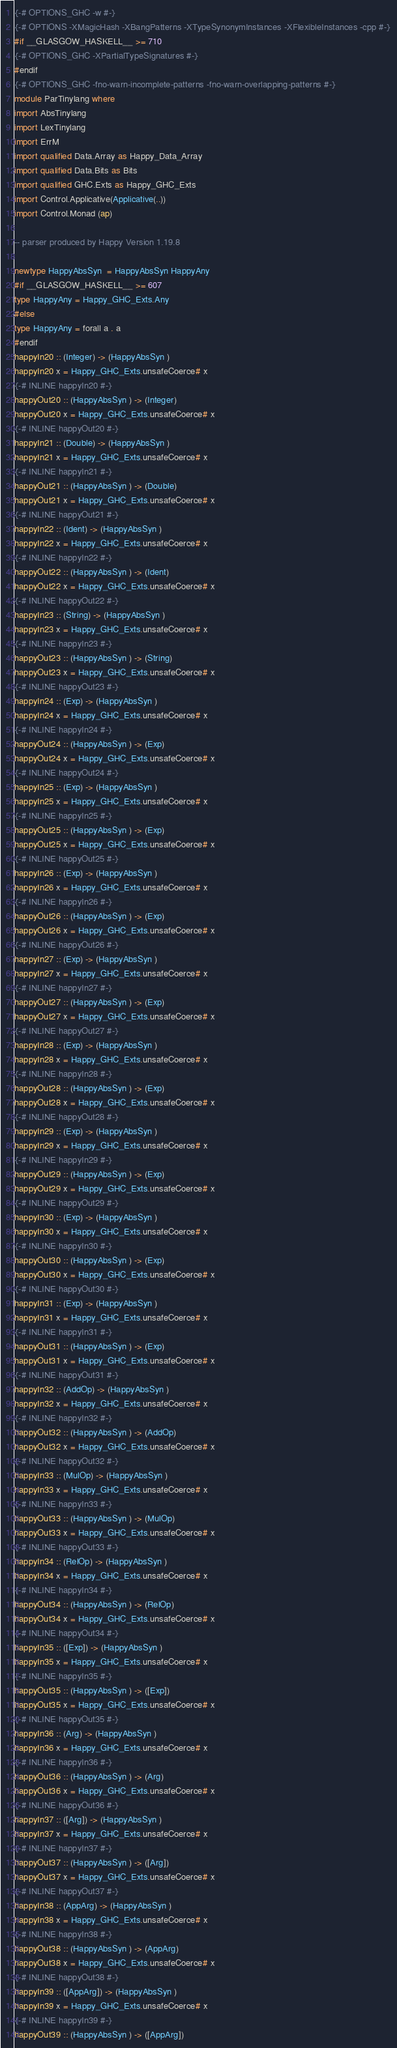Convert code to text. <code><loc_0><loc_0><loc_500><loc_500><_Haskell_>{-# OPTIONS_GHC -w #-}
{-# OPTIONS -XMagicHash -XBangPatterns -XTypeSynonymInstances -XFlexibleInstances -cpp #-}
#if __GLASGOW_HASKELL__ >= 710
{-# OPTIONS_GHC -XPartialTypeSignatures #-}
#endif
{-# OPTIONS_GHC -fno-warn-incomplete-patterns -fno-warn-overlapping-patterns #-}
module ParTinylang where
import AbsTinylang
import LexTinylang
import ErrM
import qualified Data.Array as Happy_Data_Array
import qualified Data.Bits as Bits
import qualified GHC.Exts as Happy_GHC_Exts
import Control.Applicative(Applicative(..))
import Control.Monad (ap)

-- parser produced by Happy Version 1.19.8

newtype HappyAbsSyn  = HappyAbsSyn HappyAny
#if __GLASGOW_HASKELL__ >= 607
type HappyAny = Happy_GHC_Exts.Any
#else
type HappyAny = forall a . a
#endif
happyIn20 :: (Integer) -> (HappyAbsSyn )
happyIn20 x = Happy_GHC_Exts.unsafeCoerce# x
{-# INLINE happyIn20 #-}
happyOut20 :: (HappyAbsSyn ) -> (Integer)
happyOut20 x = Happy_GHC_Exts.unsafeCoerce# x
{-# INLINE happyOut20 #-}
happyIn21 :: (Double) -> (HappyAbsSyn )
happyIn21 x = Happy_GHC_Exts.unsafeCoerce# x
{-# INLINE happyIn21 #-}
happyOut21 :: (HappyAbsSyn ) -> (Double)
happyOut21 x = Happy_GHC_Exts.unsafeCoerce# x
{-# INLINE happyOut21 #-}
happyIn22 :: (Ident) -> (HappyAbsSyn )
happyIn22 x = Happy_GHC_Exts.unsafeCoerce# x
{-# INLINE happyIn22 #-}
happyOut22 :: (HappyAbsSyn ) -> (Ident)
happyOut22 x = Happy_GHC_Exts.unsafeCoerce# x
{-# INLINE happyOut22 #-}
happyIn23 :: (String) -> (HappyAbsSyn )
happyIn23 x = Happy_GHC_Exts.unsafeCoerce# x
{-# INLINE happyIn23 #-}
happyOut23 :: (HappyAbsSyn ) -> (String)
happyOut23 x = Happy_GHC_Exts.unsafeCoerce# x
{-# INLINE happyOut23 #-}
happyIn24 :: (Exp) -> (HappyAbsSyn )
happyIn24 x = Happy_GHC_Exts.unsafeCoerce# x
{-# INLINE happyIn24 #-}
happyOut24 :: (HappyAbsSyn ) -> (Exp)
happyOut24 x = Happy_GHC_Exts.unsafeCoerce# x
{-# INLINE happyOut24 #-}
happyIn25 :: (Exp) -> (HappyAbsSyn )
happyIn25 x = Happy_GHC_Exts.unsafeCoerce# x
{-# INLINE happyIn25 #-}
happyOut25 :: (HappyAbsSyn ) -> (Exp)
happyOut25 x = Happy_GHC_Exts.unsafeCoerce# x
{-# INLINE happyOut25 #-}
happyIn26 :: (Exp) -> (HappyAbsSyn )
happyIn26 x = Happy_GHC_Exts.unsafeCoerce# x
{-# INLINE happyIn26 #-}
happyOut26 :: (HappyAbsSyn ) -> (Exp)
happyOut26 x = Happy_GHC_Exts.unsafeCoerce# x
{-# INLINE happyOut26 #-}
happyIn27 :: (Exp) -> (HappyAbsSyn )
happyIn27 x = Happy_GHC_Exts.unsafeCoerce# x
{-# INLINE happyIn27 #-}
happyOut27 :: (HappyAbsSyn ) -> (Exp)
happyOut27 x = Happy_GHC_Exts.unsafeCoerce# x
{-# INLINE happyOut27 #-}
happyIn28 :: (Exp) -> (HappyAbsSyn )
happyIn28 x = Happy_GHC_Exts.unsafeCoerce# x
{-# INLINE happyIn28 #-}
happyOut28 :: (HappyAbsSyn ) -> (Exp)
happyOut28 x = Happy_GHC_Exts.unsafeCoerce# x
{-# INLINE happyOut28 #-}
happyIn29 :: (Exp) -> (HappyAbsSyn )
happyIn29 x = Happy_GHC_Exts.unsafeCoerce# x
{-# INLINE happyIn29 #-}
happyOut29 :: (HappyAbsSyn ) -> (Exp)
happyOut29 x = Happy_GHC_Exts.unsafeCoerce# x
{-# INLINE happyOut29 #-}
happyIn30 :: (Exp) -> (HappyAbsSyn )
happyIn30 x = Happy_GHC_Exts.unsafeCoerce# x
{-# INLINE happyIn30 #-}
happyOut30 :: (HappyAbsSyn ) -> (Exp)
happyOut30 x = Happy_GHC_Exts.unsafeCoerce# x
{-# INLINE happyOut30 #-}
happyIn31 :: (Exp) -> (HappyAbsSyn )
happyIn31 x = Happy_GHC_Exts.unsafeCoerce# x
{-# INLINE happyIn31 #-}
happyOut31 :: (HappyAbsSyn ) -> (Exp)
happyOut31 x = Happy_GHC_Exts.unsafeCoerce# x
{-# INLINE happyOut31 #-}
happyIn32 :: (AddOp) -> (HappyAbsSyn )
happyIn32 x = Happy_GHC_Exts.unsafeCoerce# x
{-# INLINE happyIn32 #-}
happyOut32 :: (HappyAbsSyn ) -> (AddOp)
happyOut32 x = Happy_GHC_Exts.unsafeCoerce# x
{-# INLINE happyOut32 #-}
happyIn33 :: (MulOp) -> (HappyAbsSyn )
happyIn33 x = Happy_GHC_Exts.unsafeCoerce# x
{-# INLINE happyIn33 #-}
happyOut33 :: (HappyAbsSyn ) -> (MulOp)
happyOut33 x = Happy_GHC_Exts.unsafeCoerce# x
{-# INLINE happyOut33 #-}
happyIn34 :: (RelOp) -> (HappyAbsSyn )
happyIn34 x = Happy_GHC_Exts.unsafeCoerce# x
{-# INLINE happyIn34 #-}
happyOut34 :: (HappyAbsSyn ) -> (RelOp)
happyOut34 x = Happy_GHC_Exts.unsafeCoerce# x
{-# INLINE happyOut34 #-}
happyIn35 :: ([Exp]) -> (HappyAbsSyn )
happyIn35 x = Happy_GHC_Exts.unsafeCoerce# x
{-# INLINE happyIn35 #-}
happyOut35 :: (HappyAbsSyn ) -> ([Exp])
happyOut35 x = Happy_GHC_Exts.unsafeCoerce# x
{-# INLINE happyOut35 #-}
happyIn36 :: (Arg) -> (HappyAbsSyn )
happyIn36 x = Happy_GHC_Exts.unsafeCoerce# x
{-# INLINE happyIn36 #-}
happyOut36 :: (HappyAbsSyn ) -> (Arg)
happyOut36 x = Happy_GHC_Exts.unsafeCoerce# x
{-# INLINE happyOut36 #-}
happyIn37 :: ([Arg]) -> (HappyAbsSyn )
happyIn37 x = Happy_GHC_Exts.unsafeCoerce# x
{-# INLINE happyIn37 #-}
happyOut37 :: (HappyAbsSyn ) -> ([Arg])
happyOut37 x = Happy_GHC_Exts.unsafeCoerce# x
{-# INLINE happyOut37 #-}
happyIn38 :: (AppArg) -> (HappyAbsSyn )
happyIn38 x = Happy_GHC_Exts.unsafeCoerce# x
{-# INLINE happyIn38 #-}
happyOut38 :: (HappyAbsSyn ) -> (AppArg)
happyOut38 x = Happy_GHC_Exts.unsafeCoerce# x
{-# INLINE happyOut38 #-}
happyIn39 :: ([AppArg]) -> (HappyAbsSyn )
happyIn39 x = Happy_GHC_Exts.unsafeCoerce# x
{-# INLINE happyIn39 #-}
happyOut39 :: (HappyAbsSyn ) -> ([AppArg])</code> 